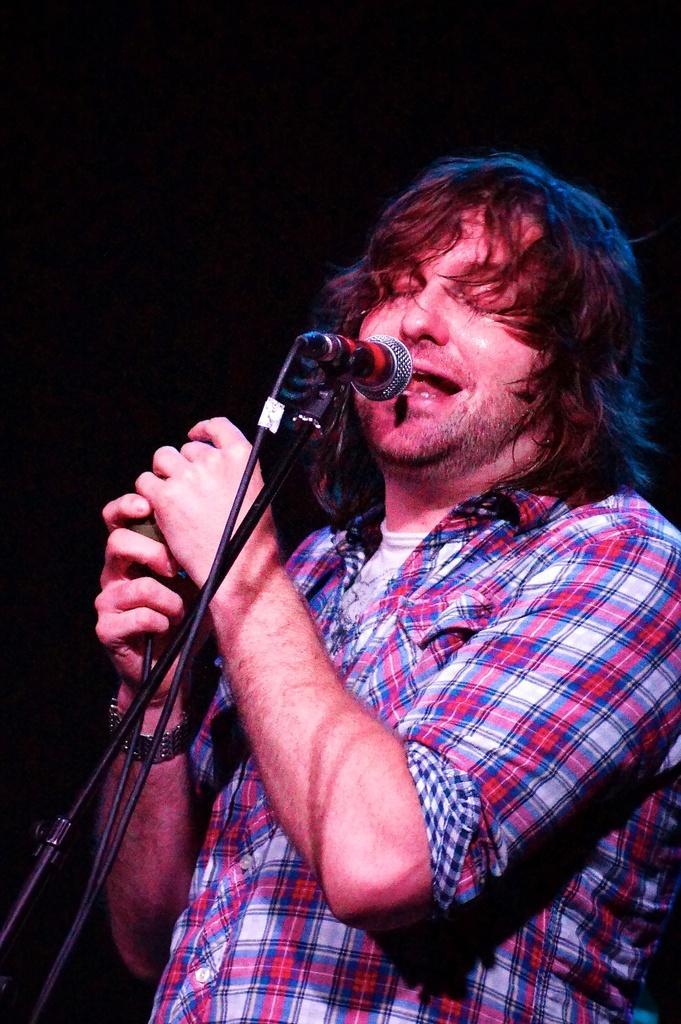In one or two sentences, can you explain what this image depicts? In this image we can see a person is standing and singing a song and in front of him a mike is there. 